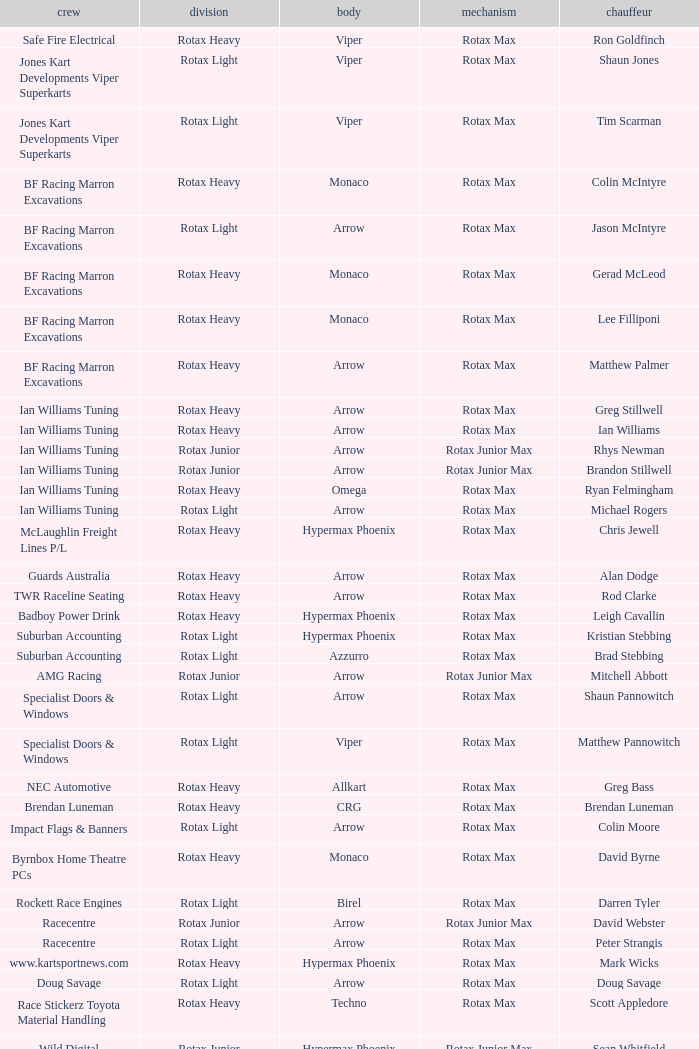Write the full table. {'header': ['crew', 'division', 'body', 'mechanism', 'chauffeur'], 'rows': [['Safe Fire Electrical', 'Rotax Heavy', 'Viper', 'Rotax Max', 'Ron Goldfinch'], ['Jones Kart Developments Viper Superkarts', 'Rotax Light', 'Viper', 'Rotax Max', 'Shaun Jones'], ['Jones Kart Developments Viper Superkarts', 'Rotax Light', 'Viper', 'Rotax Max', 'Tim Scarman'], ['BF Racing Marron Excavations', 'Rotax Heavy', 'Monaco', 'Rotax Max', 'Colin McIntyre'], ['BF Racing Marron Excavations', 'Rotax Light', 'Arrow', 'Rotax Max', 'Jason McIntyre'], ['BF Racing Marron Excavations', 'Rotax Heavy', 'Monaco', 'Rotax Max', 'Gerad McLeod'], ['BF Racing Marron Excavations', 'Rotax Heavy', 'Monaco', 'Rotax Max', 'Lee Filliponi'], ['BF Racing Marron Excavations', 'Rotax Heavy', 'Arrow', 'Rotax Max', 'Matthew Palmer'], ['Ian Williams Tuning', 'Rotax Heavy', 'Arrow', 'Rotax Max', 'Greg Stillwell'], ['Ian Williams Tuning', 'Rotax Heavy', 'Arrow', 'Rotax Max', 'Ian Williams'], ['Ian Williams Tuning', 'Rotax Junior', 'Arrow', 'Rotax Junior Max', 'Rhys Newman'], ['Ian Williams Tuning', 'Rotax Junior', 'Arrow', 'Rotax Junior Max', 'Brandon Stillwell'], ['Ian Williams Tuning', 'Rotax Heavy', 'Omega', 'Rotax Max', 'Ryan Felmingham'], ['Ian Williams Tuning', 'Rotax Light', 'Arrow', 'Rotax Max', 'Michael Rogers'], ['McLaughlin Freight Lines P/L', 'Rotax Heavy', 'Hypermax Phoenix', 'Rotax Max', 'Chris Jewell'], ['Guards Australia', 'Rotax Heavy', 'Arrow', 'Rotax Max', 'Alan Dodge'], ['TWR Raceline Seating', 'Rotax Heavy', 'Arrow', 'Rotax Max', 'Rod Clarke'], ['Badboy Power Drink', 'Rotax Heavy', 'Hypermax Phoenix', 'Rotax Max', 'Leigh Cavallin'], ['Suburban Accounting', 'Rotax Light', 'Hypermax Phoenix', 'Rotax Max', 'Kristian Stebbing'], ['Suburban Accounting', 'Rotax Light', 'Azzurro', 'Rotax Max', 'Brad Stebbing'], ['AMG Racing', 'Rotax Junior', 'Arrow', 'Rotax Junior Max', 'Mitchell Abbott'], ['Specialist Doors & Windows', 'Rotax Light', 'Arrow', 'Rotax Max', 'Shaun Pannowitch'], ['Specialist Doors & Windows', 'Rotax Light', 'Viper', 'Rotax Max', 'Matthew Pannowitch'], ['NEC Automotive', 'Rotax Heavy', 'Allkart', 'Rotax Max', 'Greg Bass'], ['Brendan Luneman', 'Rotax Heavy', 'CRG', 'Rotax Max', 'Brendan Luneman'], ['Impact Flags & Banners', 'Rotax Light', 'Arrow', 'Rotax Max', 'Colin Moore'], ['Byrnbox Home Theatre PCs', 'Rotax Heavy', 'Monaco', 'Rotax Max', 'David Byrne'], ['Rockett Race Engines', 'Rotax Light', 'Birel', 'Rotax Max', 'Darren Tyler'], ['Racecentre', 'Rotax Junior', 'Arrow', 'Rotax Junior Max', 'David Webster'], ['Racecentre', 'Rotax Light', 'Arrow', 'Rotax Max', 'Peter Strangis'], ['www.kartsportnews.com', 'Rotax Heavy', 'Hypermax Phoenix', 'Rotax Max', 'Mark Wicks'], ['Doug Savage', 'Rotax Light', 'Arrow', 'Rotax Max', 'Doug Savage'], ['Race Stickerz Toyota Material Handling', 'Rotax Heavy', 'Techno', 'Rotax Max', 'Scott Appledore'], ['Wild Digital', 'Rotax Junior', 'Hypermax Phoenix', 'Rotax Junior Max', 'Sean Whitfield'], ['John Bartlett', 'Rotax Heavy', 'Hypermax Phoenix', 'Rotax Max', 'John Bartlett']]} Which team does Colin Moore drive for? Impact Flags & Banners. 